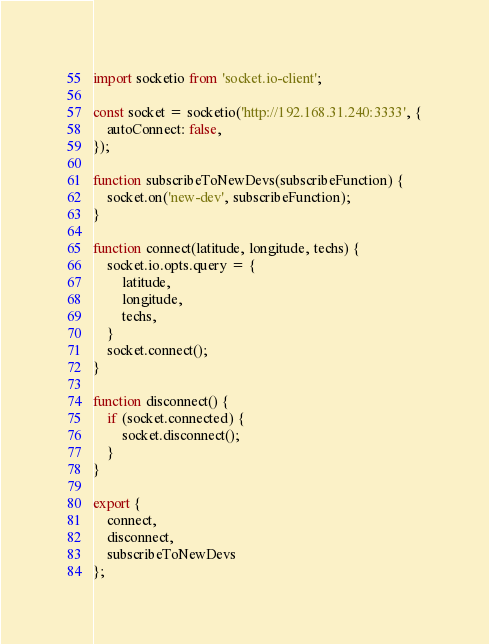Convert code to text. <code><loc_0><loc_0><loc_500><loc_500><_JavaScript_>import socketio from 'socket.io-client';

const socket = socketio('http://192.168.31.240:3333', {
    autoConnect: false,
});

function subscribeToNewDevs(subscribeFunction) {
    socket.on('new-dev', subscribeFunction);
}

function connect(latitude, longitude, techs) {
    socket.io.opts.query = {
        latitude,
        longitude,
        techs,
    }
    socket.connect();
}

function disconnect() {
    if (socket.connected) {
        socket.disconnect();
    }
}

export {
    connect,
    disconnect,
    subscribeToNewDevs
};</code> 